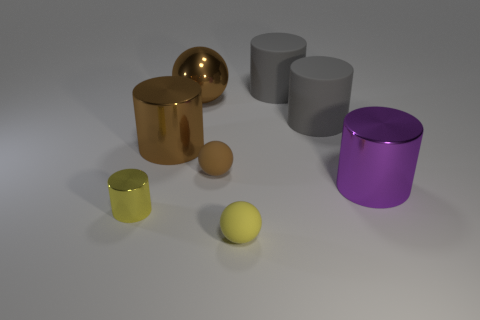What is the shape of the large metal object that is both in front of the big brown ball and to the left of the purple cylinder?
Offer a very short reply. Cylinder. What number of other yellow metal objects have the same shape as the small yellow metal thing?
Provide a succinct answer. 0. There is a brown ball that is the same material as the purple cylinder; what is its size?
Provide a short and direct response. Large. What number of brown shiny cylinders have the same size as the yellow sphere?
Give a very brief answer. 0. What is the size of the matte ball that is the same color as the tiny shiny cylinder?
Make the answer very short. Small. What is the color of the large cylinder to the left of the yellow thing that is right of the yellow metallic cylinder?
Offer a very short reply. Brown. Are there any matte balls that have the same color as the small shiny cylinder?
Make the answer very short. Yes. What is the color of the ball that is the same size as the brown metallic cylinder?
Your answer should be very brief. Brown. Are the brown object that is to the left of the brown shiny sphere and the tiny yellow cylinder made of the same material?
Offer a terse response. Yes. There is a large gray matte cylinder that is in front of the big brown sphere left of the large purple metallic object; are there any big brown metal cylinders that are on the right side of it?
Your answer should be compact. No. 